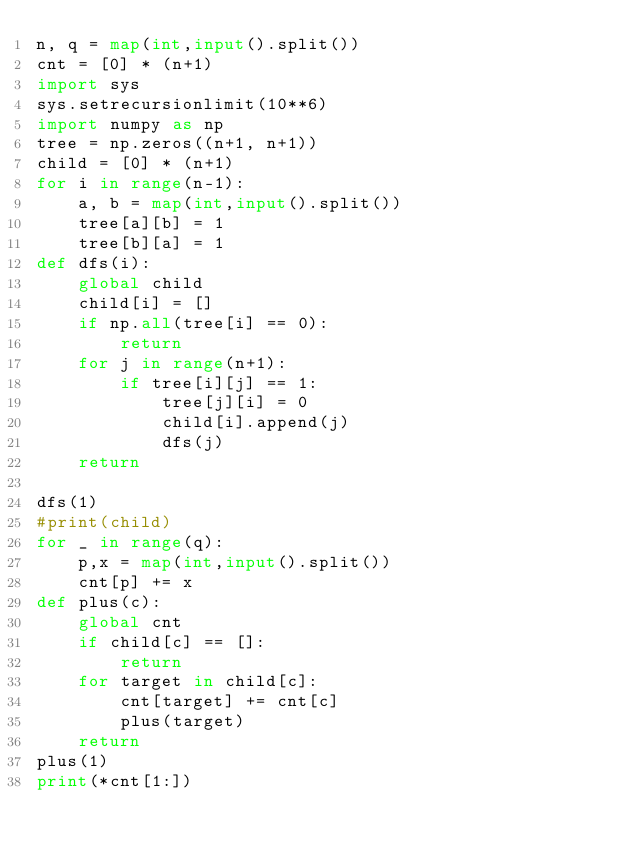<code> <loc_0><loc_0><loc_500><loc_500><_Python_>n, q = map(int,input().split())
cnt = [0] * (n+1)
import sys
sys.setrecursionlimit(10**6)
import numpy as np
tree = np.zeros((n+1, n+1))
child = [0] * (n+1)
for i in range(n-1):
    a, b = map(int,input().split())
    tree[a][b] = 1
    tree[b][a] = 1
def dfs(i):
    global child
    child[i] = []
    if np.all(tree[i] == 0):
        return
    for j in range(n+1):
        if tree[i][j] == 1:
            tree[j][i] = 0
            child[i].append(j)
            dfs(j)
    return

dfs(1)
#print(child)
for _ in range(q):
    p,x = map(int,input().split())
    cnt[p] += x
def plus(c):
    global cnt
    if child[c] == []:
        return
    for target in child[c]:
        cnt[target] += cnt[c]
        plus(target)
    return
plus(1)
print(*cnt[1:])</code> 